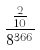<formula> <loc_0><loc_0><loc_500><loc_500>\frac { \frac { 2 } { 1 0 } } { 8 ^ { 3 6 6 } }</formula> 